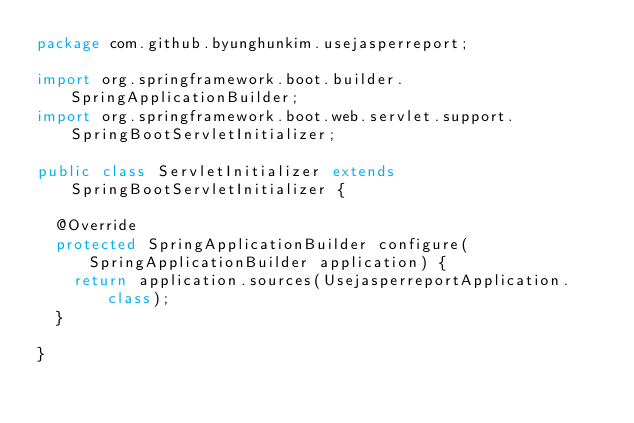Convert code to text. <code><loc_0><loc_0><loc_500><loc_500><_Java_>package com.github.byunghunkim.usejasperreport;

import org.springframework.boot.builder.SpringApplicationBuilder;
import org.springframework.boot.web.servlet.support.SpringBootServletInitializer;

public class ServletInitializer extends SpringBootServletInitializer {

	@Override
	protected SpringApplicationBuilder configure(SpringApplicationBuilder application) {
		return application.sources(UsejasperreportApplication.class);
	}

}
</code> 